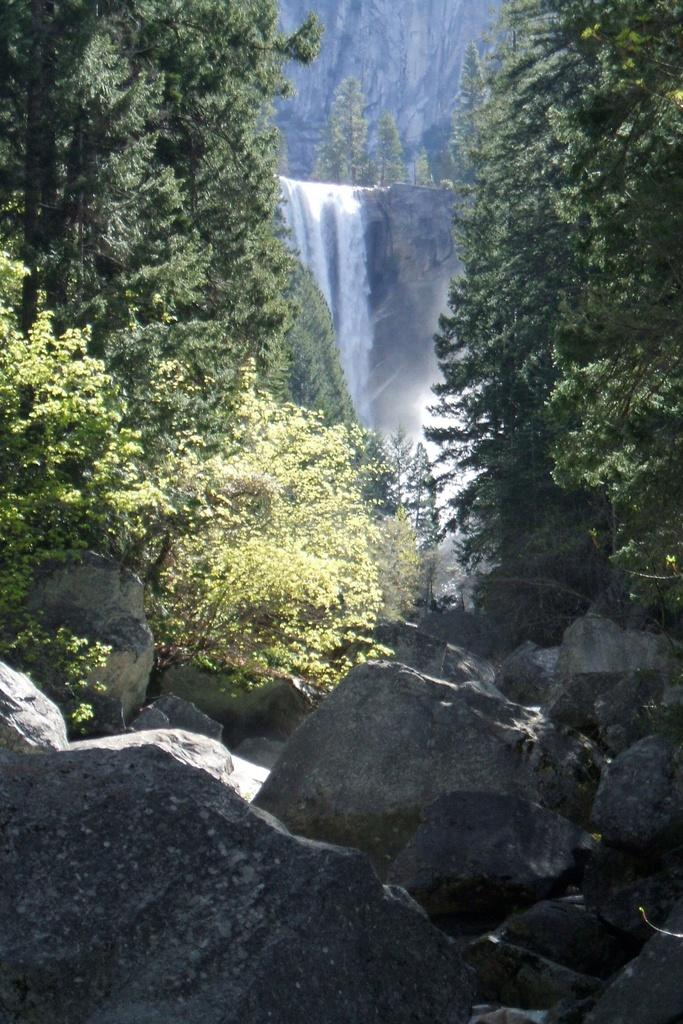What is at the bottom of the image? There are stones at the bottom of the image. What can be seen on the sides of the image? There are trees on either side of the image. What is located at the back of the image? There is a waterfall at the back side of the image. Can you tell me how many partners are visible in the image? There are no partners present in the image; it features stones, trees, and a waterfall. What type of camp can be seen in the image? There is no camp present in the image. 